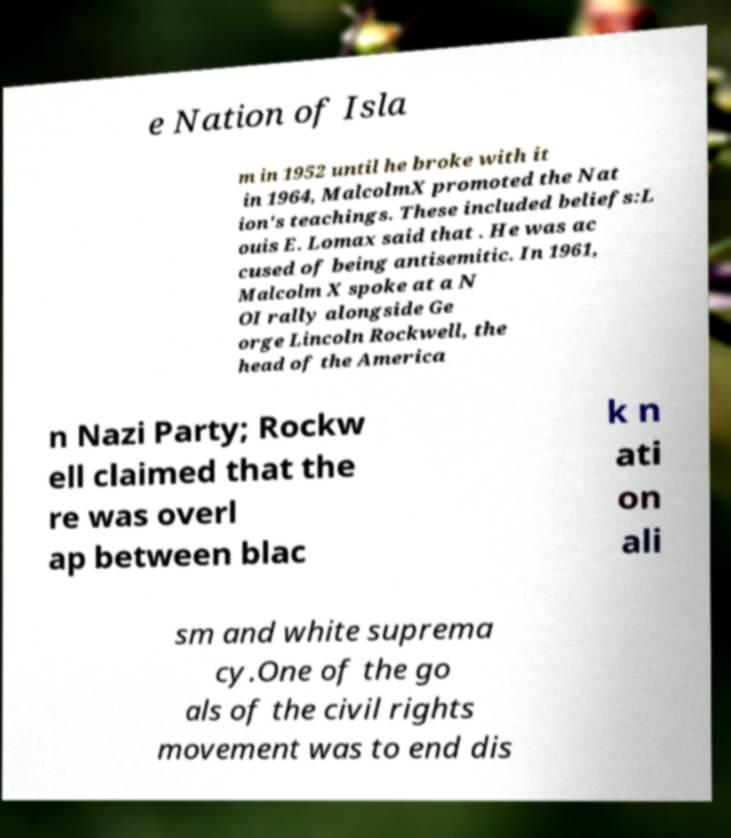Can you read and provide the text displayed in the image?This photo seems to have some interesting text. Can you extract and type it out for me? e Nation of Isla m in 1952 until he broke with it in 1964, MalcolmX promoted the Nat ion's teachings. These included beliefs:L ouis E. Lomax said that . He was ac cused of being antisemitic. In 1961, Malcolm X spoke at a N OI rally alongside Ge orge Lincoln Rockwell, the head of the America n Nazi Party; Rockw ell claimed that the re was overl ap between blac k n ati on ali sm and white suprema cy.One of the go als of the civil rights movement was to end dis 